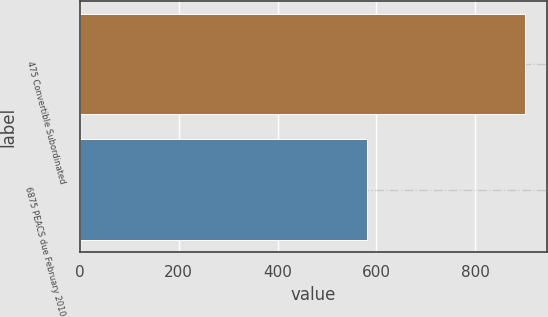Convert chart to OTSL. <chart><loc_0><loc_0><loc_500><loc_500><bar_chart><fcel>475 Convertible Subordinated<fcel>6875 PEACS due February 2010<nl><fcel>900<fcel>580<nl></chart> 